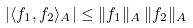Convert formula to latex. <formula><loc_0><loc_0><loc_500><loc_500>| \langle f _ { 1 } , f _ { 2 } \rangle _ { A } | \leq \| f _ { 1 } \| _ { A } \, \| f _ { 2 } \| _ { A }</formula> 